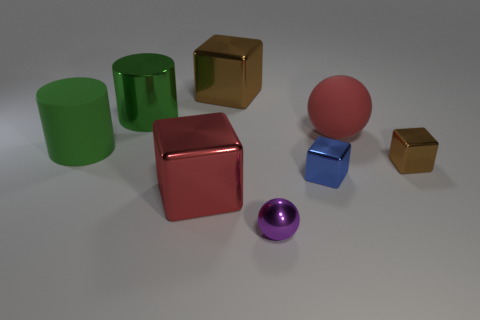What material is the red cube that is to the left of the red thing that is on the right side of the tiny metal ball in front of the red cube made of?
Provide a short and direct response. Metal. What size is the shiny object that is behind the tiny blue cube and in front of the big red sphere?
Make the answer very short. Small. What number of spheres are small blue objects or purple metallic things?
Offer a very short reply. 1. There is a matte thing that is the same size as the rubber cylinder; what color is it?
Provide a short and direct response. Red. Are there any other things that have the same shape as the green rubber object?
Provide a short and direct response. Yes. There is another large object that is the same shape as the red metallic thing; what color is it?
Provide a succinct answer. Brown. How many objects are either metal objects or small metallic things that are right of the purple ball?
Provide a short and direct response. 6. Is the number of tiny metallic spheres that are to the left of the large green shiny cylinder less than the number of tiny shiny objects?
Provide a short and direct response. Yes. What is the size of the brown shiny object that is in front of the large green cylinder that is behind the large red object behind the tiny blue object?
Your response must be concise. Small. There is a cube that is to the right of the large brown metal block and in front of the small brown thing; what is its color?
Give a very brief answer. Blue. 